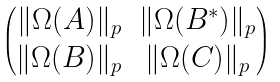Convert formula to latex. <formula><loc_0><loc_0><loc_500><loc_500>\begin{pmatrix} \| \Omega ( A ) \| _ { p } & \| \Omega ( B ^ { \ast } ) \| _ { p } \\ \| \Omega ( B ) \| _ { p } & \| \Omega ( C ) \| _ { p } \end{pmatrix}</formula> 